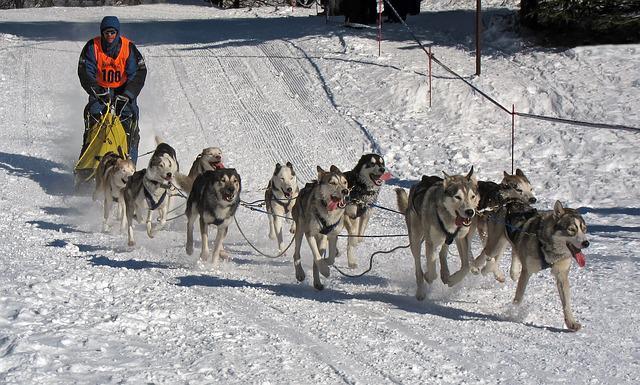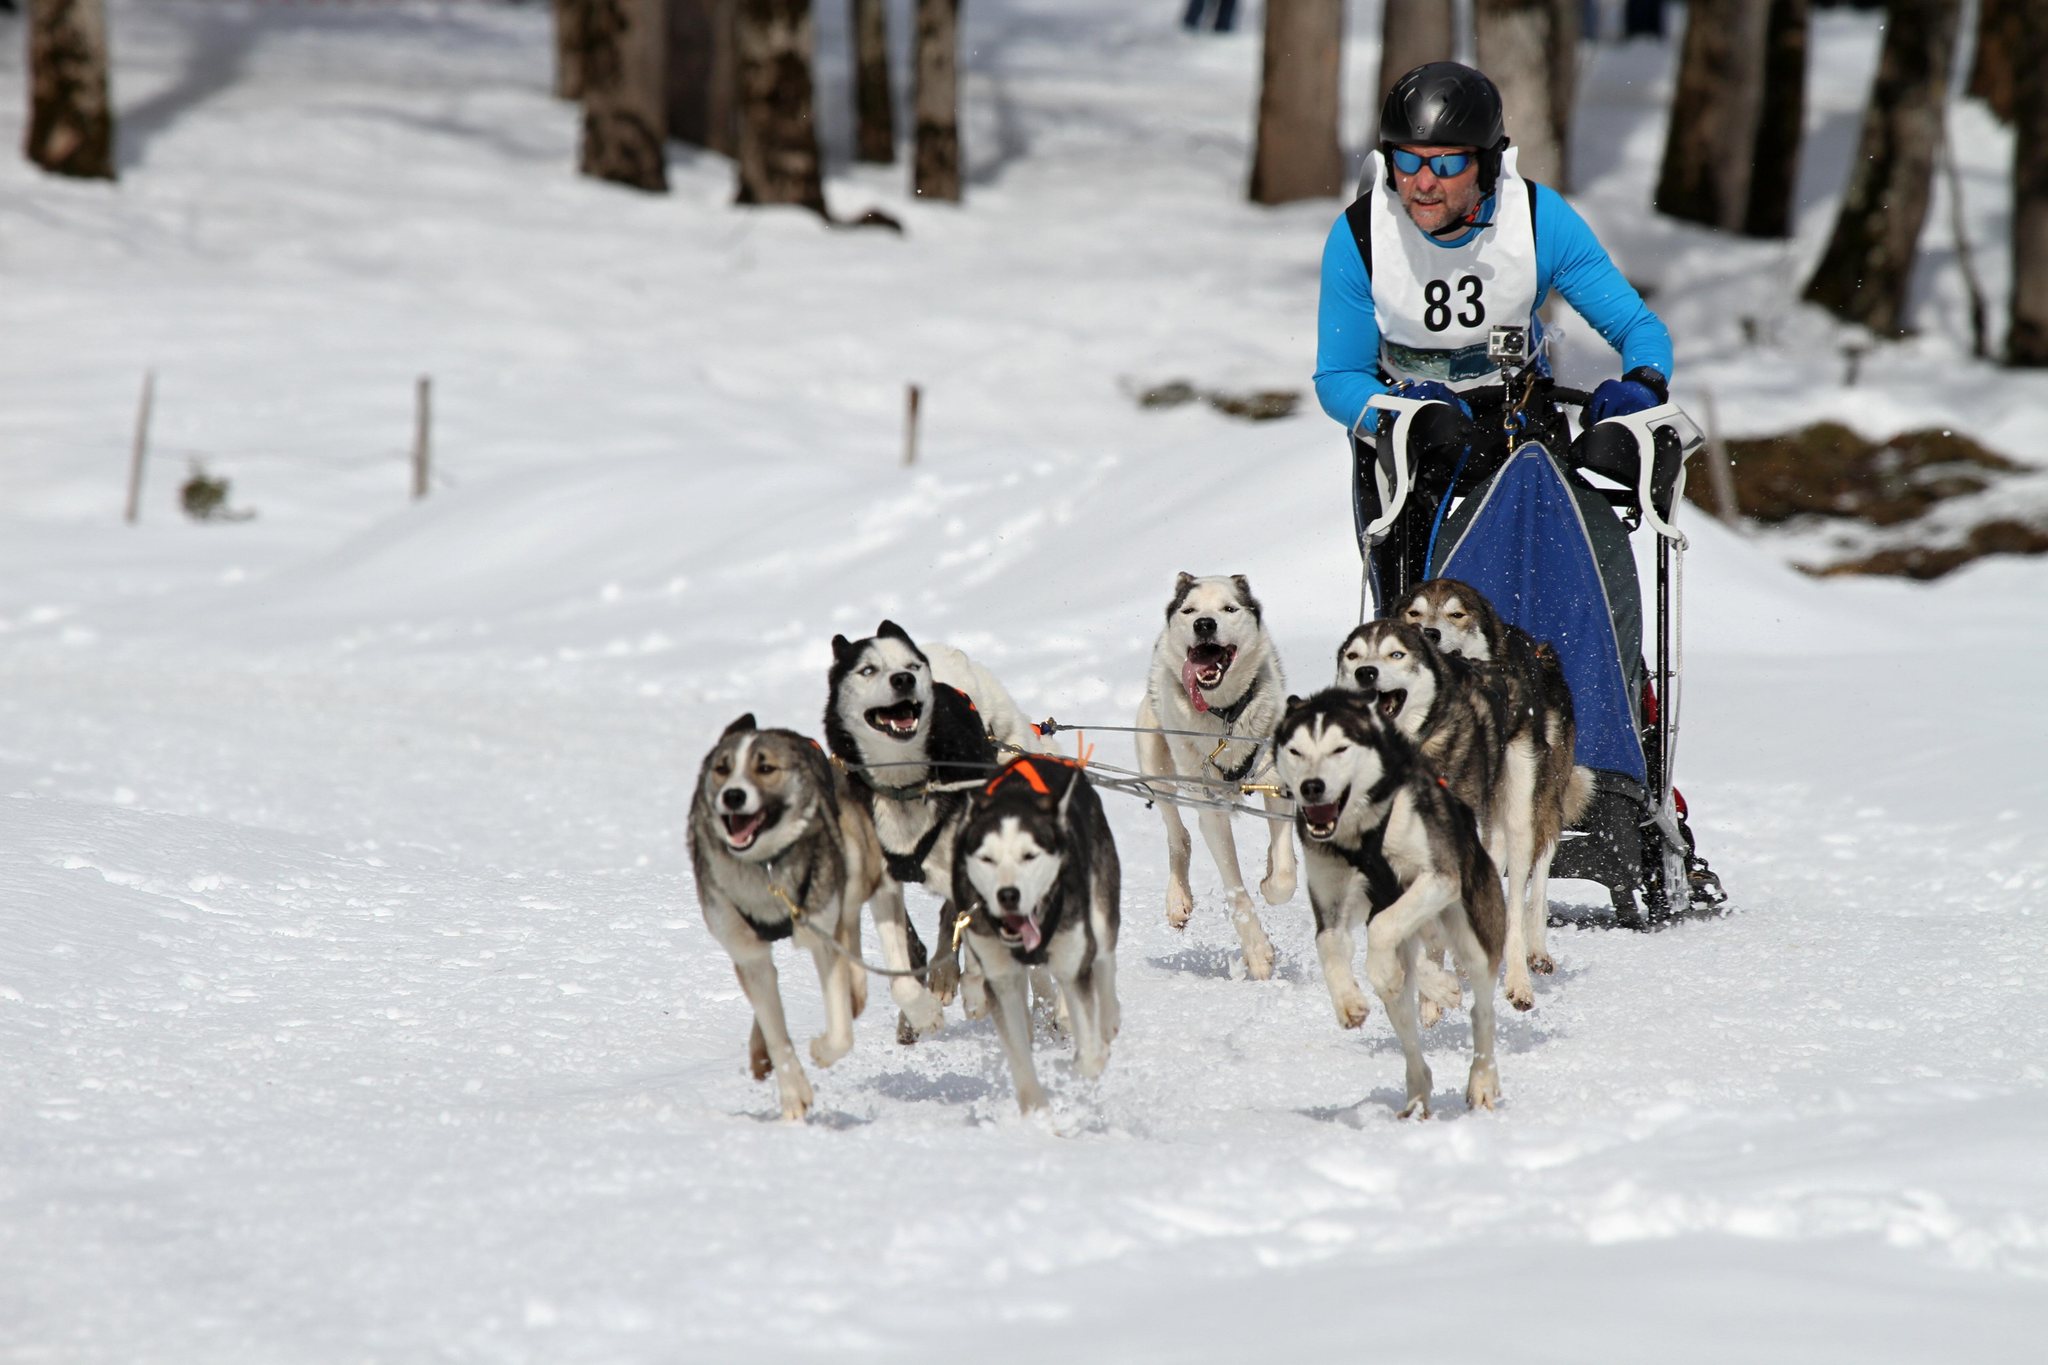The first image is the image on the left, the second image is the image on the right. Evaluate the accuracy of this statement regarding the images: "one of the images contain only one wolf". Is it true? Answer yes or no. No. 